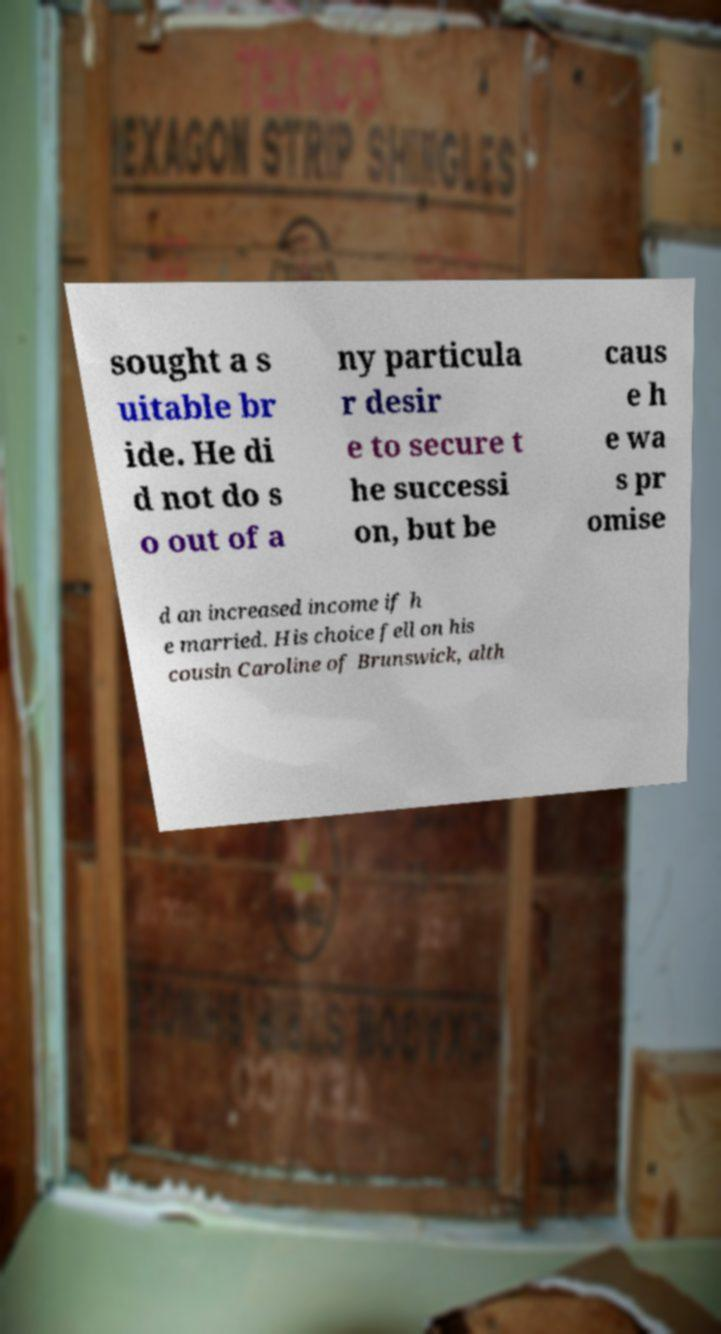Please read and relay the text visible in this image. What does it say? sought a s uitable br ide. He di d not do s o out of a ny particula r desir e to secure t he successi on, but be caus e h e wa s pr omise d an increased income if h e married. His choice fell on his cousin Caroline of Brunswick, alth 